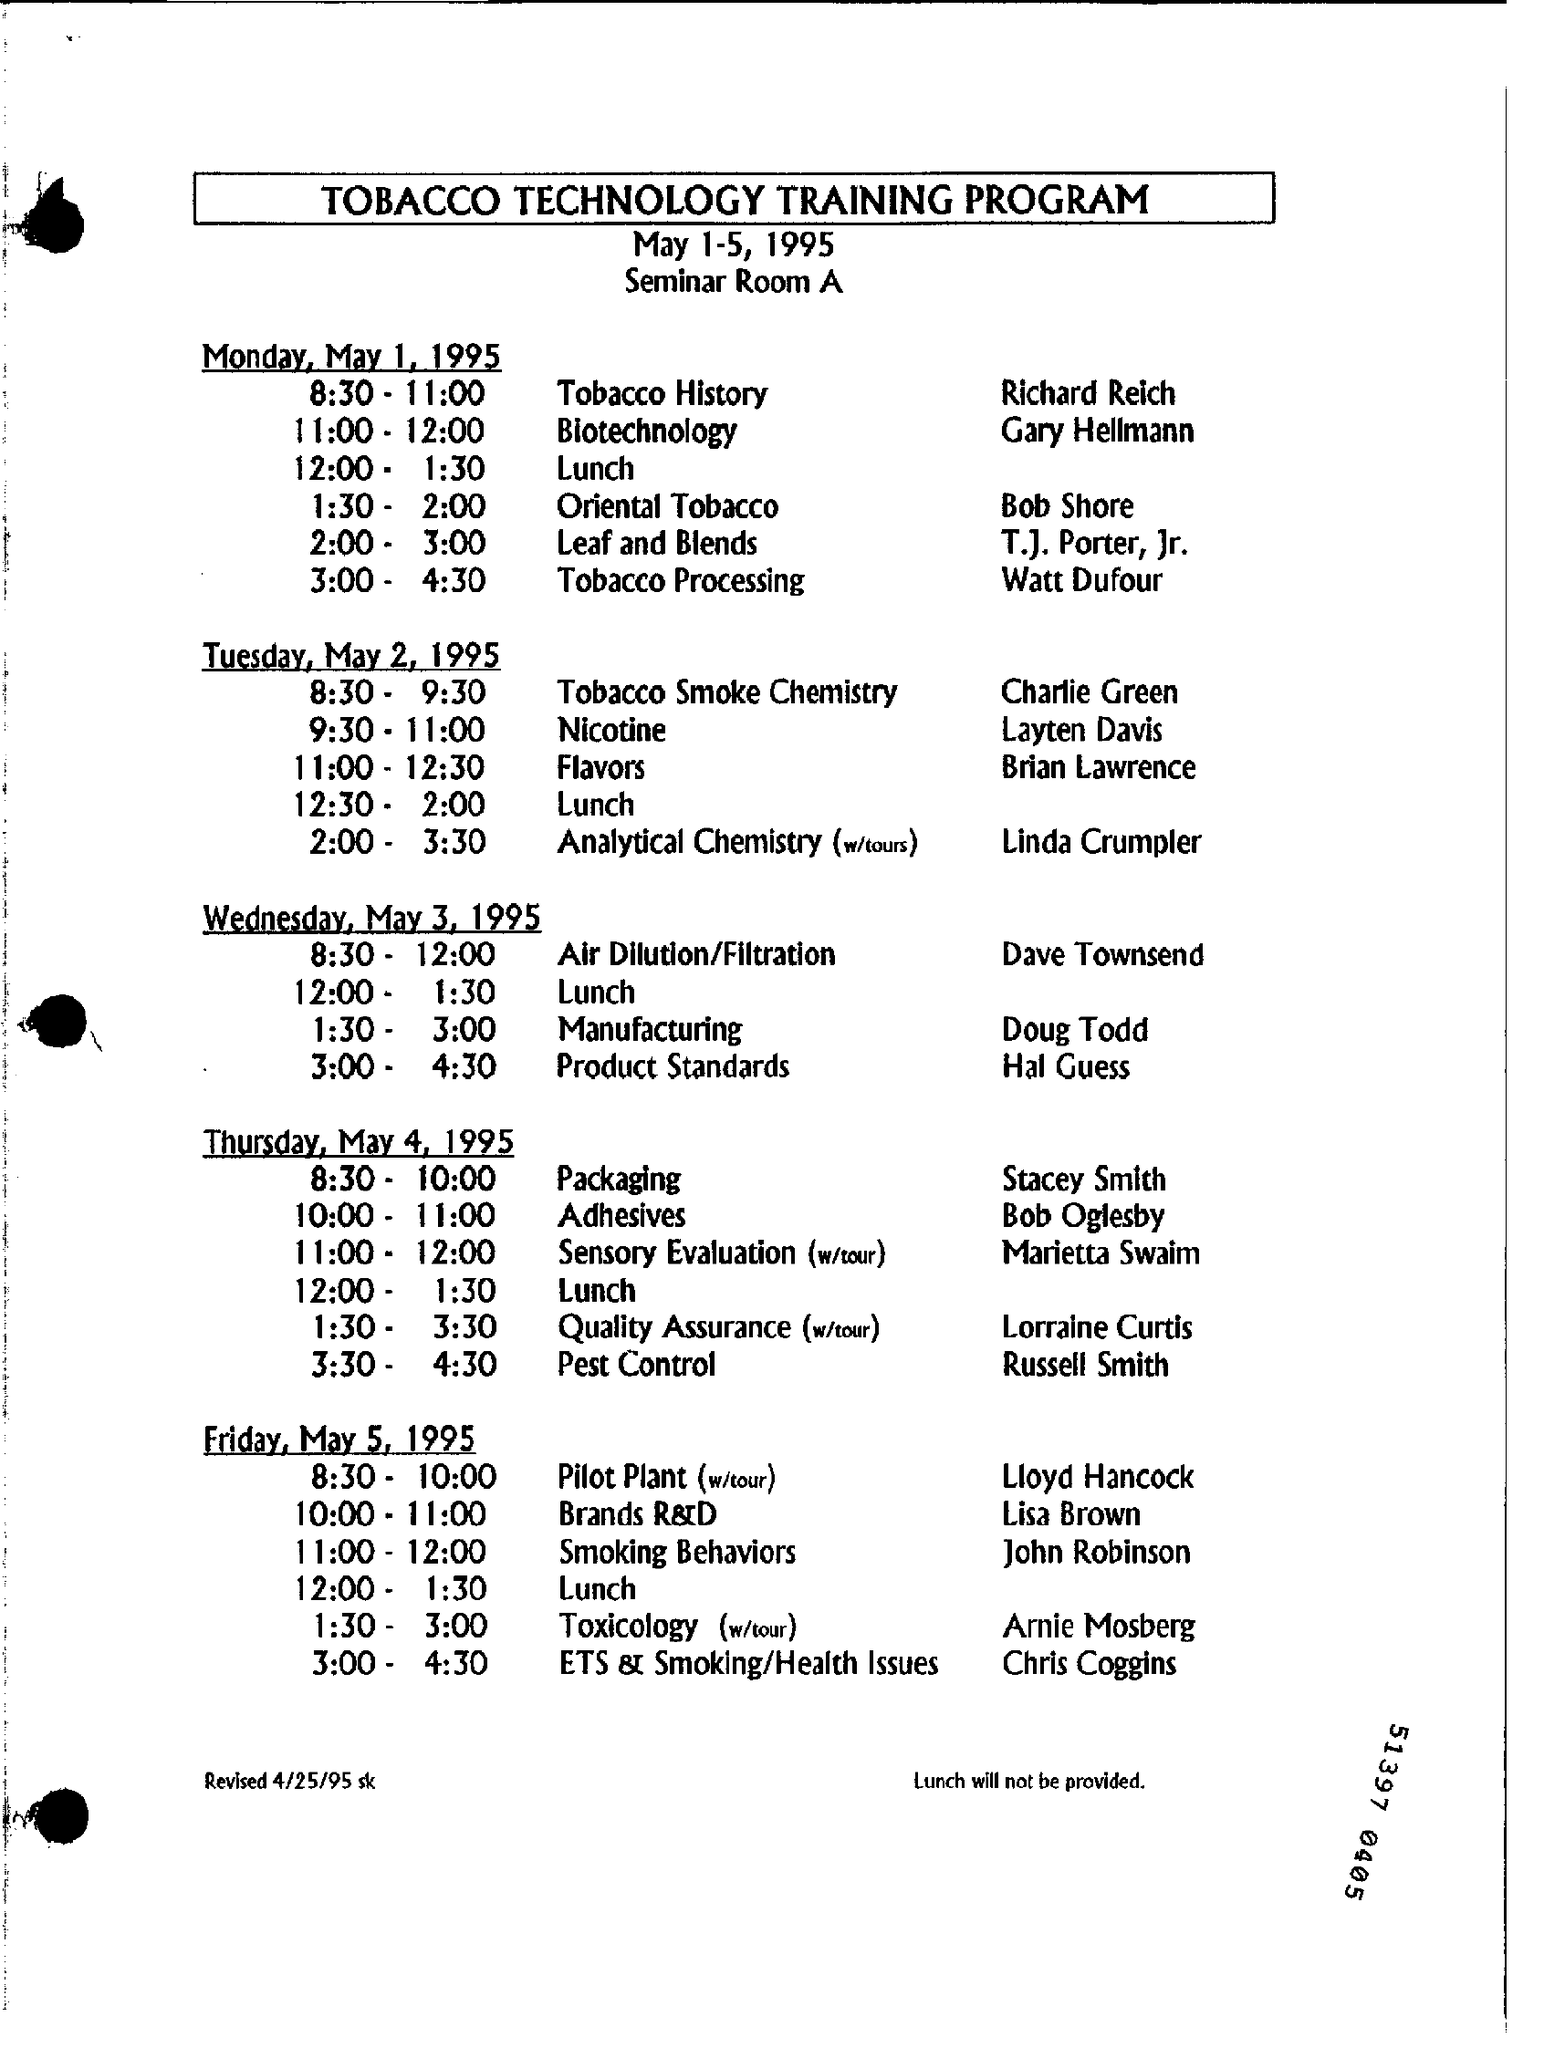Outline some significant characteristics in this image. The title of the document is "What is the document title? TOBACCO TECHNOLOGY TRAINING PROGRAM..". On Wednesday, Doug Todd will be discussing the topic of manufacturing. The document was revised on April 25th, 1995. The seminar will be held in Seminar Room A. The program is scheduled to take place from May 1st to May 5th, 1995. 